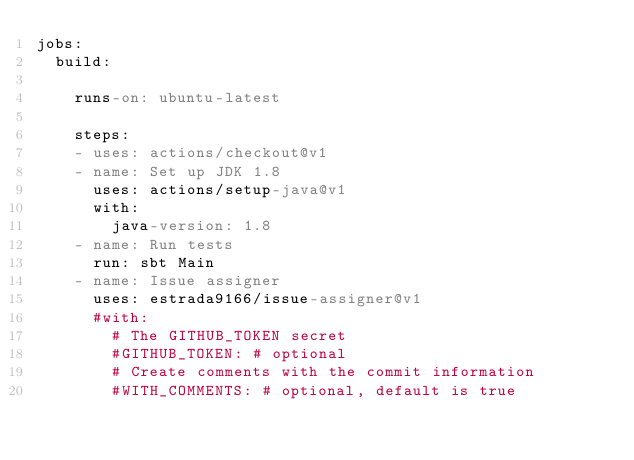Convert code to text. <code><loc_0><loc_0><loc_500><loc_500><_YAML_>jobs:
  build:

    runs-on: ubuntu-latest

    steps:
    - uses: actions/checkout@v1
    - name: Set up JDK 1.8
      uses: actions/setup-java@v1
      with:
        java-version: 1.8
    - name: Run tests
      run: sbt Main
    - name: Issue assigner
      uses: estrada9166/issue-assigner@v1
      #with:
        # The GITHUB_TOKEN secret
        #GITHUB_TOKEN: # optional
        # Create comments with the commit information
        #WITH_COMMENTS: # optional, default is true
</code> 